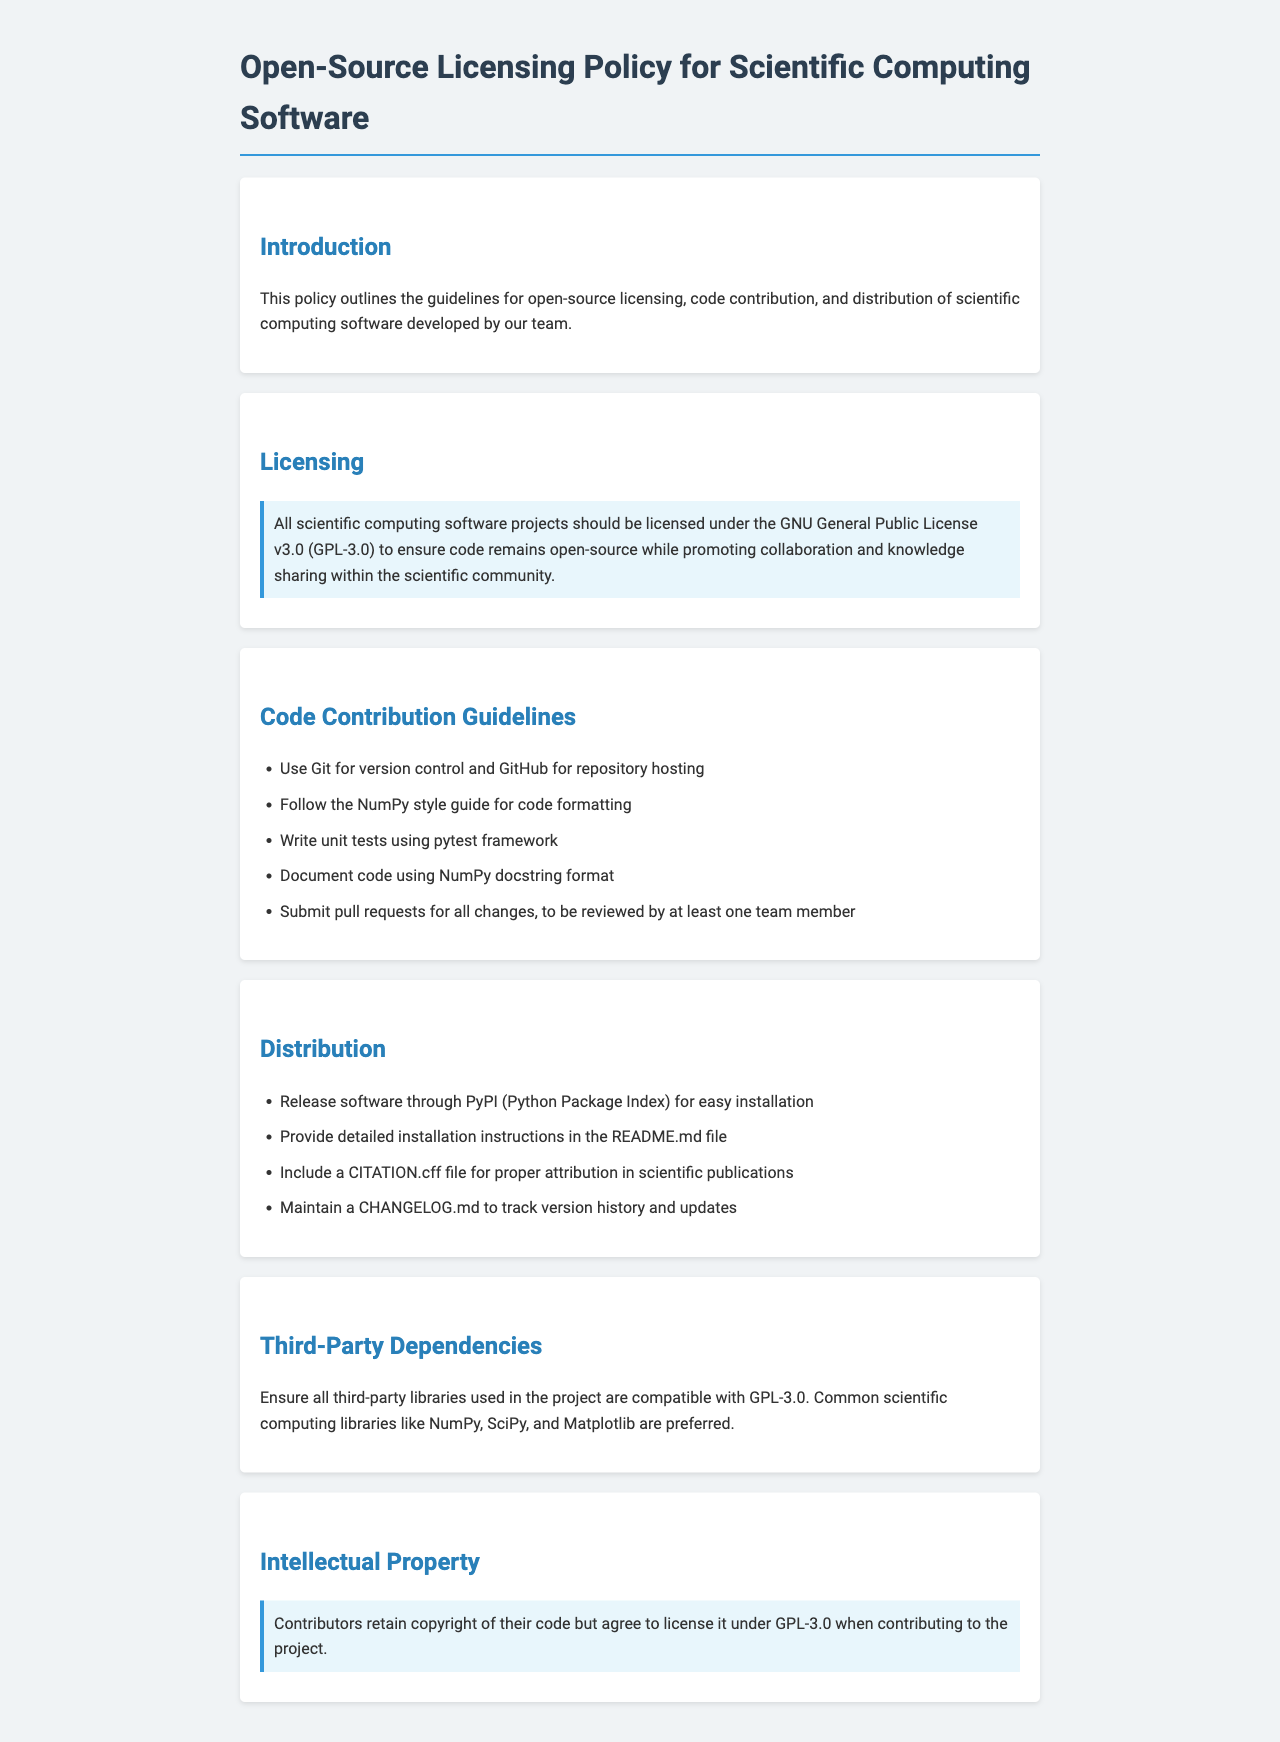What is the license used for the software? The document states that all scientific computing software projects should be licensed under the GNU General Public License v3.0.
Answer: GNU General Public License v3.0 (GPL-3.0) How should code contributions be reviewed? The guidelines specify that all changes should be submitted as pull requests to be reviewed by at least one team member.
Answer: By at least one team member What style guide should be followed for code formatting? The document indicates that contributors should follow the NumPy style guide for code formatting.
Answer: NumPy style guide Which framework is recommended for unit testing? The document recommends using the pytest framework for writing unit tests.
Answer: pytest What file should be included for proper attribution in publications? The guidelines mention including a CITATION.cff file in the distribution for proper attribution in scientific publications.
Answer: CITATION.cff How are third-party libraries required to be? The policy states that all third-party libraries used in the project must be compatible with GPL-3.0.
Answer: Compatible with GPL-3.0 